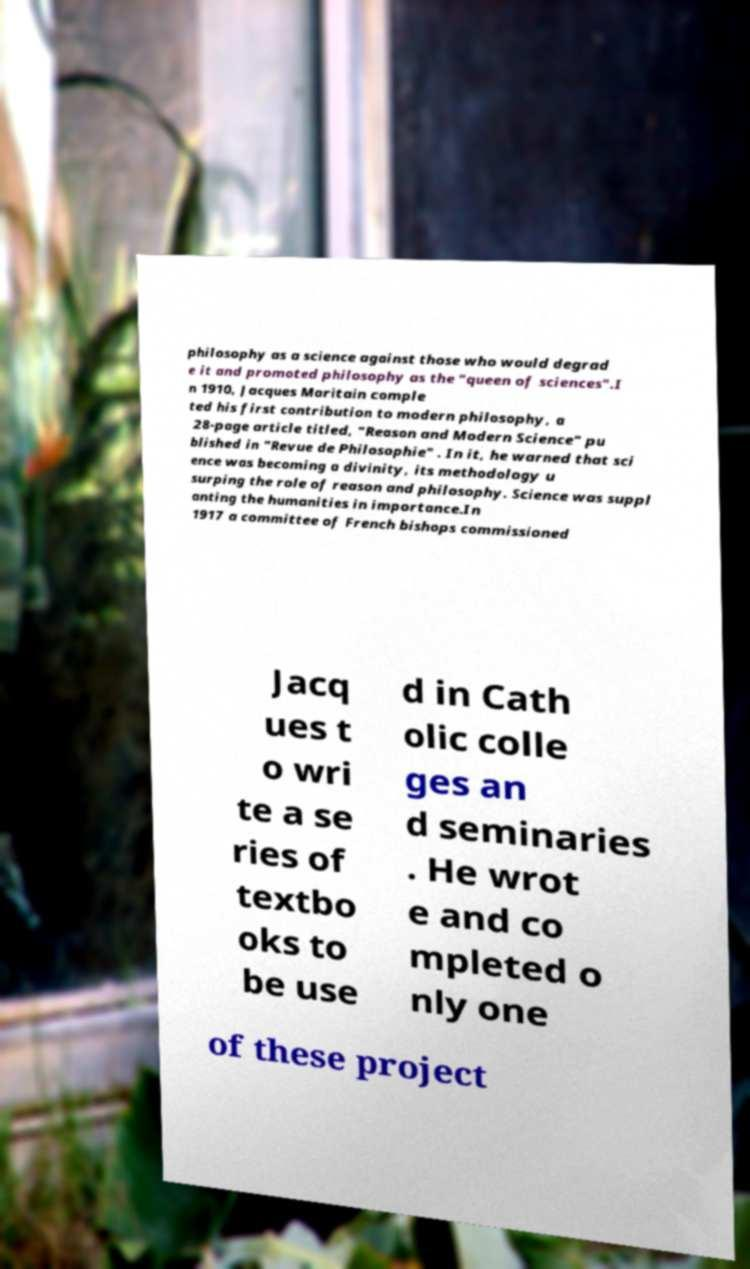I need the written content from this picture converted into text. Can you do that? philosophy as a science against those who would degrad e it and promoted philosophy as the "queen of sciences".I n 1910, Jacques Maritain comple ted his first contribution to modern philosophy, a 28-page article titled, "Reason and Modern Science" pu blished in "Revue de Philosophie" . In it, he warned that sci ence was becoming a divinity, its methodology u surping the role of reason and philosophy. Science was suppl anting the humanities in importance.In 1917 a committee of French bishops commissioned Jacq ues t o wri te a se ries of textbo oks to be use d in Cath olic colle ges an d seminaries . He wrot e and co mpleted o nly one of these project 